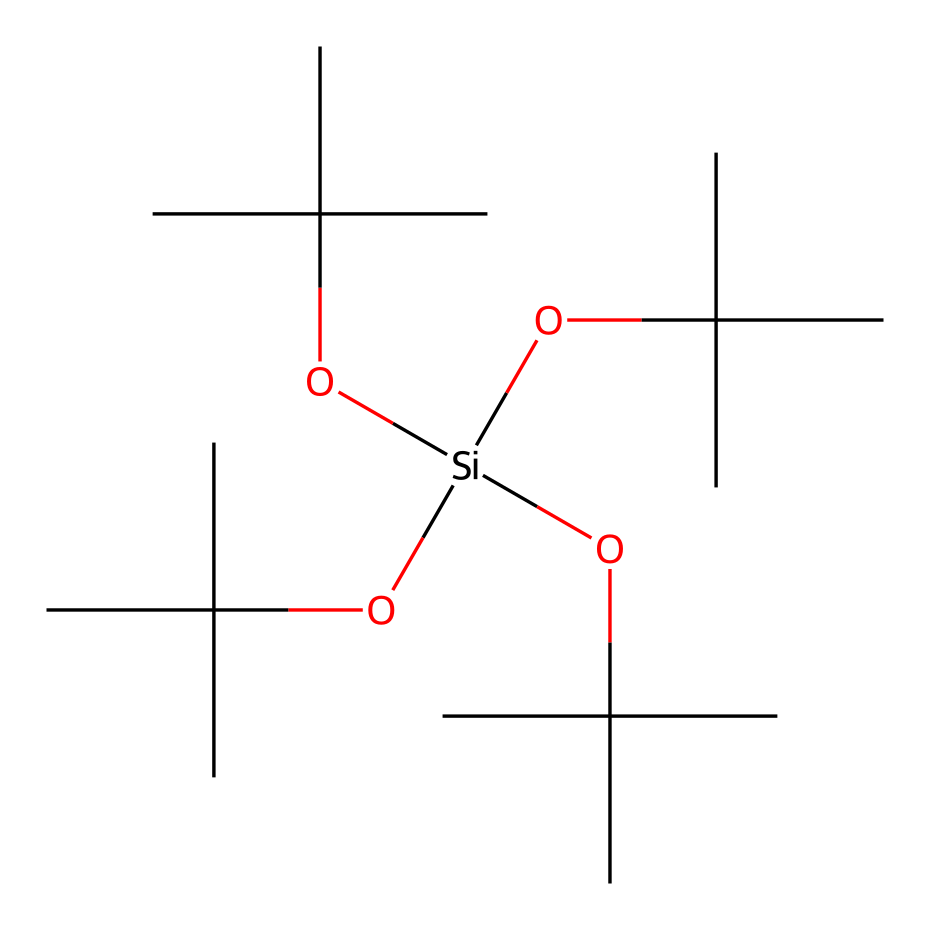What is the central atom in this chemical structure? The chemical structure shows that silicon (Si) is the central atom because it is surrounded by four alkoxy groups. This is identified by the notation [Si] in the SMILES representation.
Answer: silicon How many alkoxy (OC) groups are attached to the central silicon atom? By analyzing the SMILES representation, we can see that there are four OC groups (denoted as OC(C)(C)C) bonded to the silicon atom, which are identified by the repeating segments.
Answer: four What type of bonding is primarily observed in this organosilicon compound? The bonding in this compound involves covalent bonds between the silicon atom and the oxygen atoms of the alkoxy groups, as evidenced by the connectivity shown in the SMILES, which represents strong electron-sharing characteristic of covalent bonding.
Answer: covalent What functional groups are present in this organosilicon compound? The presence of the OC groups indicates that the functional groups present are alkoxy groups, specifically tertiary butoxy groups, inferred from the groups denoted by (C)(C)C attached to the oxygen in the OC notation.
Answer: alkoxy Why might this organosilicon compound be used in lip gloss formulations? The structure includes numerous bulky alkoxy groups, which contribute to a glossy and smooth texture, enhancing the overall aesthetic and application properties of lip gloss, making it appealing for cosmetic use.
Answer: glossy texture How does the presence of silicon in this compound affect its properties compared to organic compounds? The inclusion of silicon in the structure introduces unique properties such as improved thermal stability and moisture resistance, which are typical advantages of organosilicon compounds compared to purely organic compounds.
Answer: improved stability 